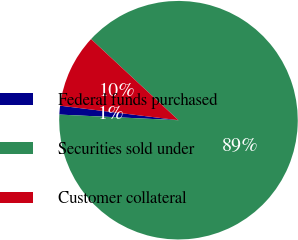Convert chart to OTSL. <chart><loc_0><loc_0><loc_500><loc_500><pie_chart><fcel>Federal funds purchased<fcel>Securities sold under<fcel>Customer collateral<nl><fcel>1.19%<fcel>88.86%<fcel>9.96%<nl></chart> 